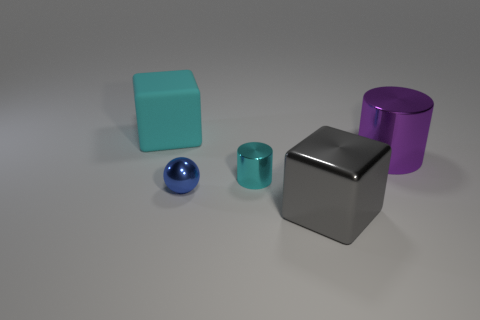Does the cyan rubber thing have the same size as the cyan metal thing?
Your response must be concise. No. There is a large rubber object; what number of big cyan rubber objects are left of it?
Offer a terse response. 0. Are there an equal number of big cubes that are on the left side of the large cyan matte thing and cyan matte objects to the right of the gray object?
Ensure brevity in your answer.  Yes. Does the tiny cyan object in front of the matte thing have the same shape as the big purple metallic thing?
Offer a terse response. Yes. Is there any other thing that is made of the same material as the big purple object?
Ensure brevity in your answer.  Yes. There is a purple thing; is it the same size as the cube in front of the cyan matte object?
Your response must be concise. Yes. How many other things are the same color as the big matte block?
Your response must be concise. 1. Are there any tiny metallic things in front of the tiny shiny cylinder?
Your answer should be compact. Yes. What number of things are either tiny gray rubber blocks or blocks to the left of the gray object?
Give a very brief answer. 1. There is a big thing that is to the right of the gray shiny block; are there any cyan rubber things that are to the right of it?
Make the answer very short. No. 